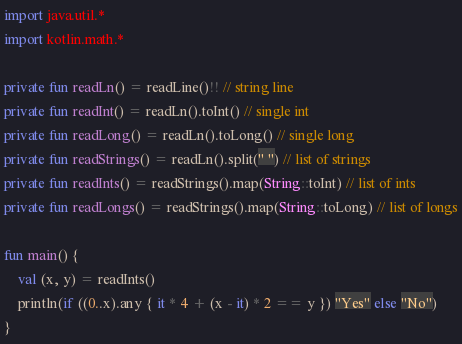<code> <loc_0><loc_0><loc_500><loc_500><_Kotlin_>import java.util.*
import kotlin.math.*

private fun readLn() = readLine()!! // string line
private fun readInt() = readLn().toInt() // single int
private fun readLong() = readLn().toLong() // single long
private fun readStrings() = readLn().split(" ") // list of strings
private fun readInts() = readStrings().map(String::toInt) // list of ints
private fun readLongs() = readStrings().map(String::toLong) // list of longs

fun main() {
    val (x, y) = readInts()
    println(if ((0..x).any { it * 4 + (x - it) * 2 == y }) "Yes" else "No")
}
</code> 